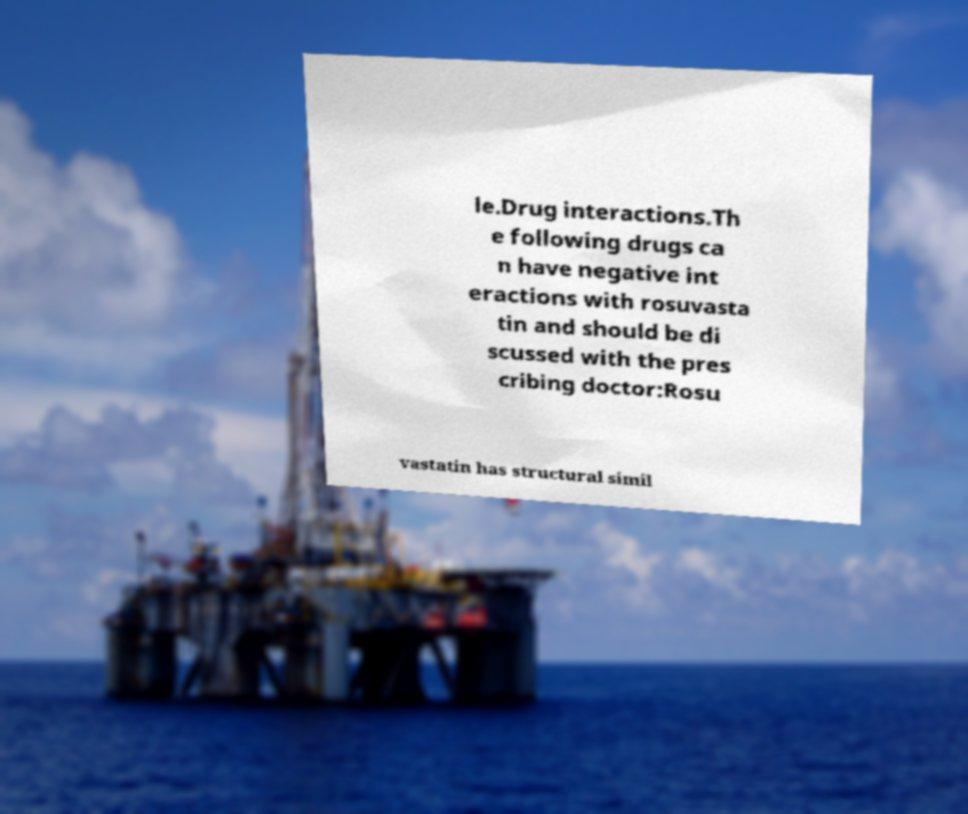Please identify and transcribe the text found in this image. le.Drug interactions.Th e following drugs ca n have negative int eractions with rosuvasta tin and should be di scussed with the pres cribing doctor:Rosu vastatin has structural simil 